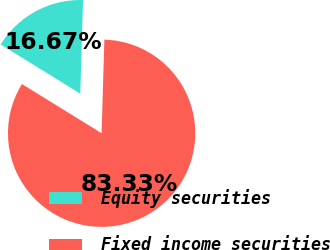<chart> <loc_0><loc_0><loc_500><loc_500><pie_chart><fcel>Equity securities<fcel>Fixed income securities<nl><fcel>16.67%<fcel>83.33%<nl></chart> 